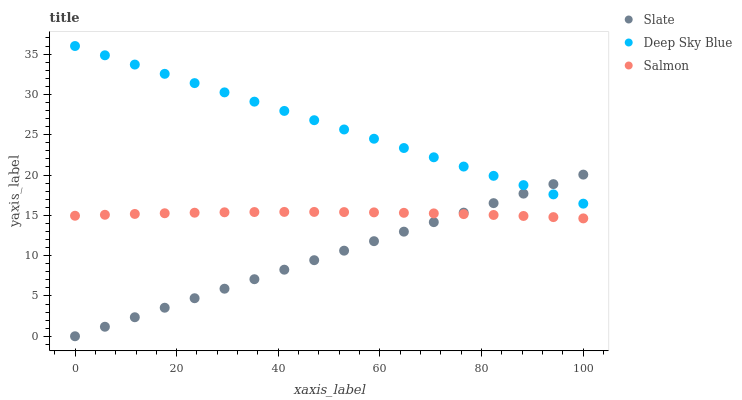Does Slate have the minimum area under the curve?
Answer yes or no. Yes. Does Deep Sky Blue have the maximum area under the curve?
Answer yes or no. Yes. Does Salmon have the minimum area under the curve?
Answer yes or no. No. Does Salmon have the maximum area under the curve?
Answer yes or no. No. Is Slate the smoothest?
Answer yes or no. Yes. Is Salmon the roughest?
Answer yes or no. Yes. Is Deep Sky Blue the smoothest?
Answer yes or no. No. Is Deep Sky Blue the roughest?
Answer yes or no. No. Does Slate have the lowest value?
Answer yes or no. Yes. Does Salmon have the lowest value?
Answer yes or no. No. Does Deep Sky Blue have the highest value?
Answer yes or no. Yes. Does Salmon have the highest value?
Answer yes or no. No. Is Salmon less than Deep Sky Blue?
Answer yes or no. Yes. Is Deep Sky Blue greater than Salmon?
Answer yes or no. Yes. Does Salmon intersect Slate?
Answer yes or no. Yes. Is Salmon less than Slate?
Answer yes or no. No. Is Salmon greater than Slate?
Answer yes or no. No. Does Salmon intersect Deep Sky Blue?
Answer yes or no. No. 